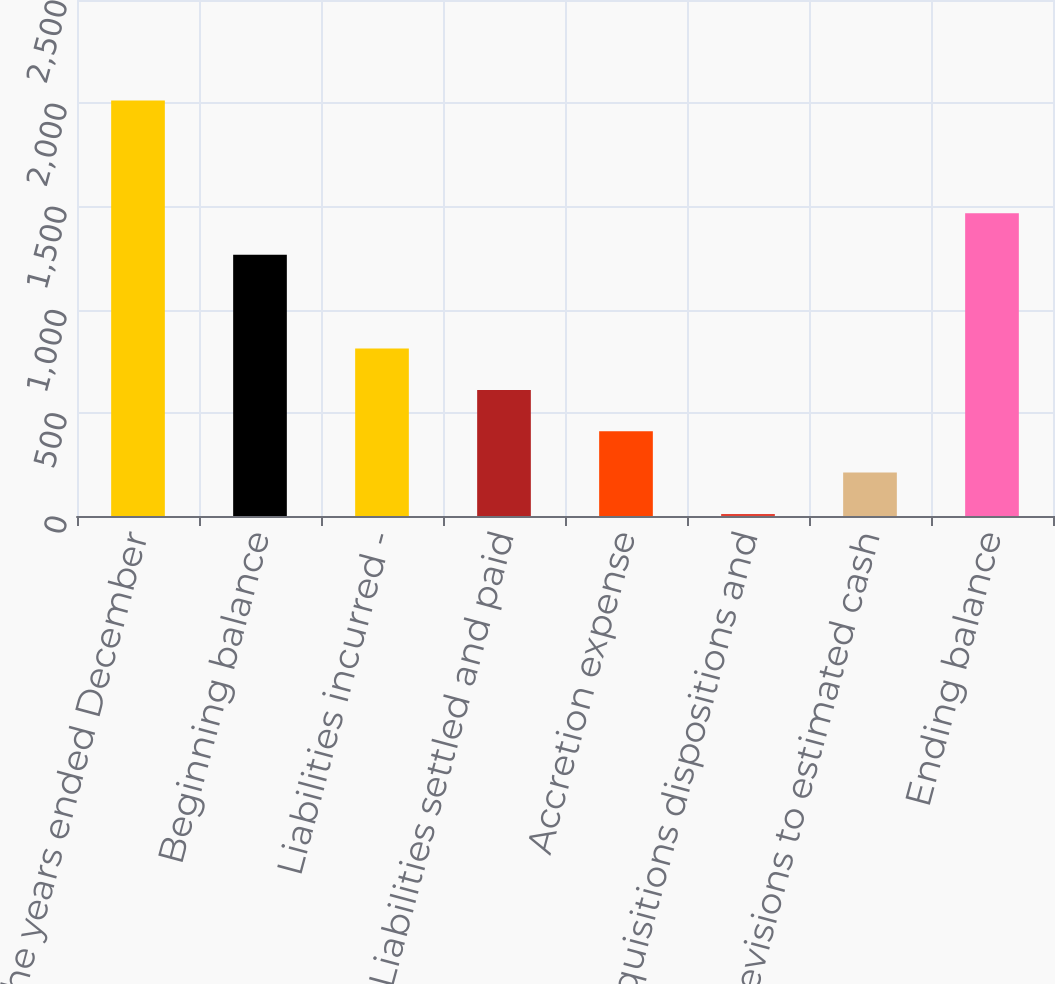Convert chart to OTSL. <chart><loc_0><loc_0><loc_500><loc_500><bar_chart><fcel>For the years ended December<fcel>Beginning balance<fcel>Liabilities incurred -<fcel>Liabilities settled and paid<fcel>Accretion expense<fcel>Acquisitions dispositions and<fcel>Revisions to estimated cash<fcel>Ending balance<nl><fcel>2013<fcel>1266<fcel>811.2<fcel>610.9<fcel>410.6<fcel>10<fcel>210.3<fcel>1466.3<nl></chart> 